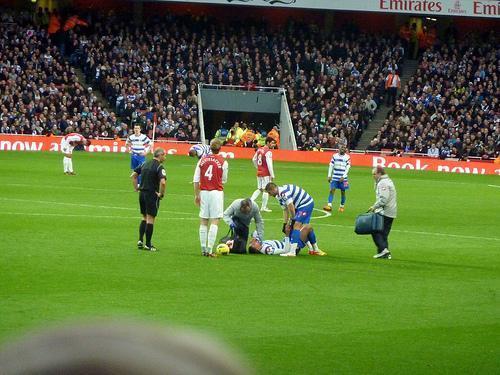How many people are lying on the grass?
Give a very brief answer. 1. 